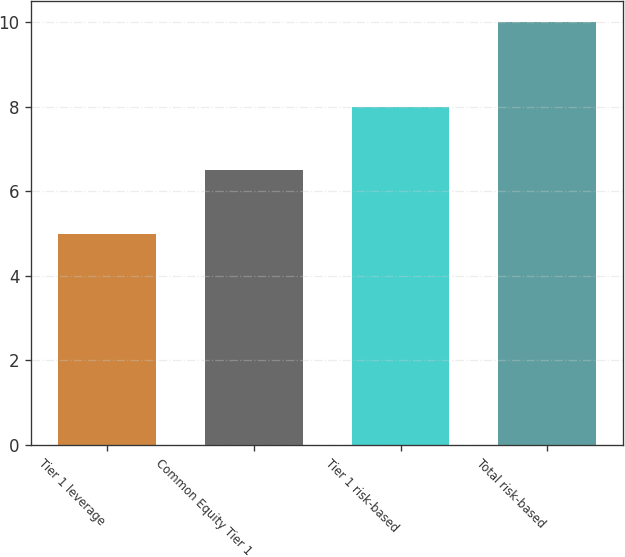Convert chart. <chart><loc_0><loc_0><loc_500><loc_500><bar_chart><fcel>Tier 1 leverage<fcel>Common Equity Tier 1<fcel>Tier 1 risk-based<fcel>Total risk-based<nl><fcel>5<fcel>6.5<fcel>8<fcel>10<nl></chart> 